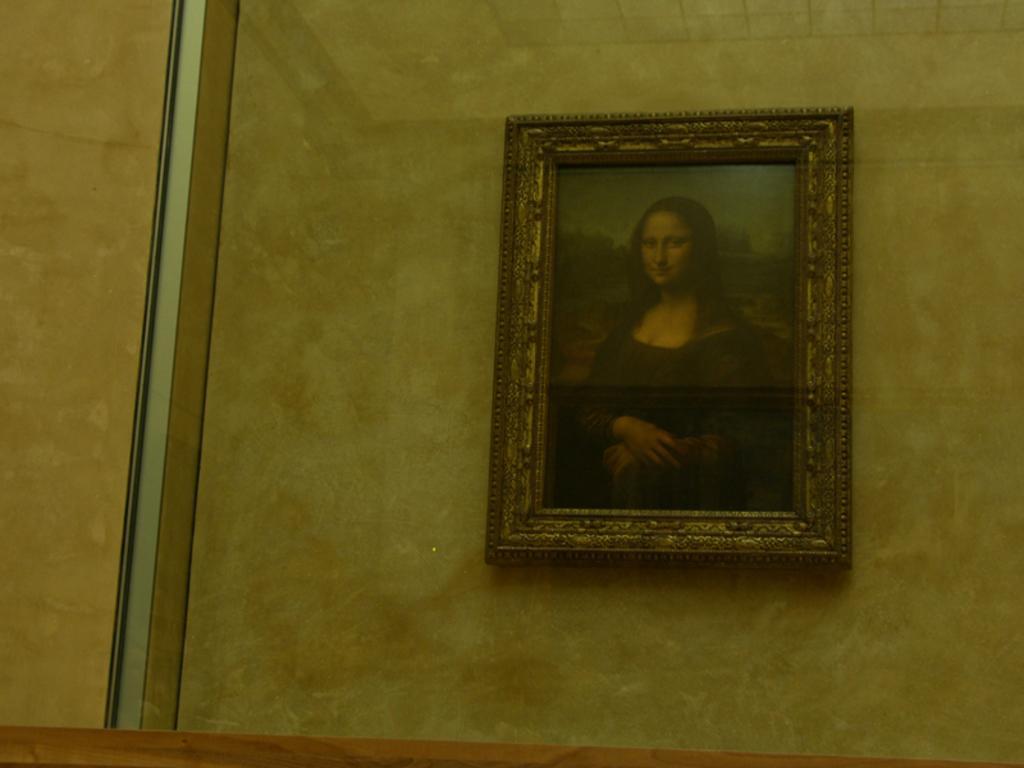Describe this image in one or two sentences. In the image inside the glass there is a wall. There is a photo frame of a lady on the wall. 